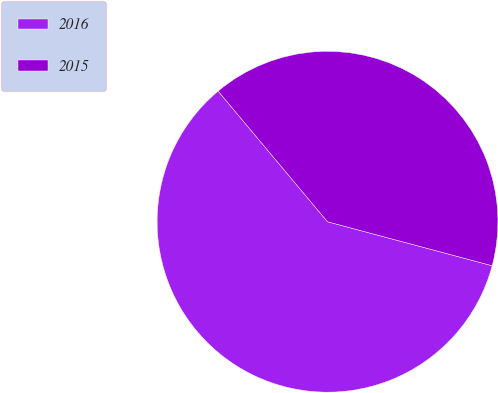Convert chart. <chart><loc_0><loc_0><loc_500><loc_500><pie_chart><fcel>2016<fcel>2015<nl><fcel>59.75%<fcel>40.25%<nl></chart> 